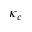Convert formula to latex. <formula><loc_0><loc_0><loc_500><loc_500>\kappa _ { c }</formula> 